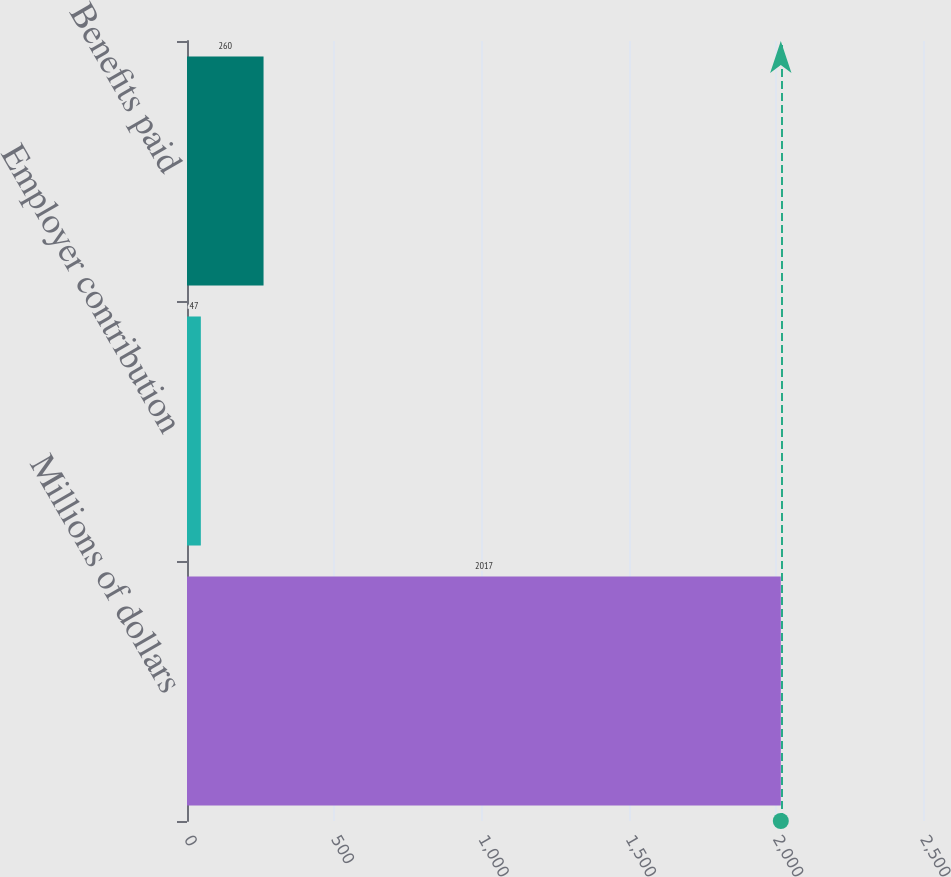Convert chart. <chart><loc_0><loc_0><loc_500><loc_500><bar_chart><fcel>Millions of dollars<fcel>Employer contribution<fcel>Benefits paid<nl><fcel>2017<fcel>47<fcel>260<nl></chart> 